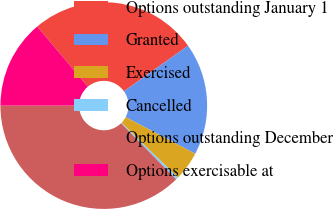Convert chart. <chart><loc_0><loc_0><loc_500><loc_500><pie_chart><fcel>Options outstanding January 1<fcel>Granted<fcel>Exercised<fcel>Cancelled<fcel>Options outstanding December<fcel>Options exercisable at<nl><fcel>26.31%<fcel>17.55%<fcel>4.55%<fcel>0.39%<fcel>37.34%<fcel>13.86%<nl></chart> 